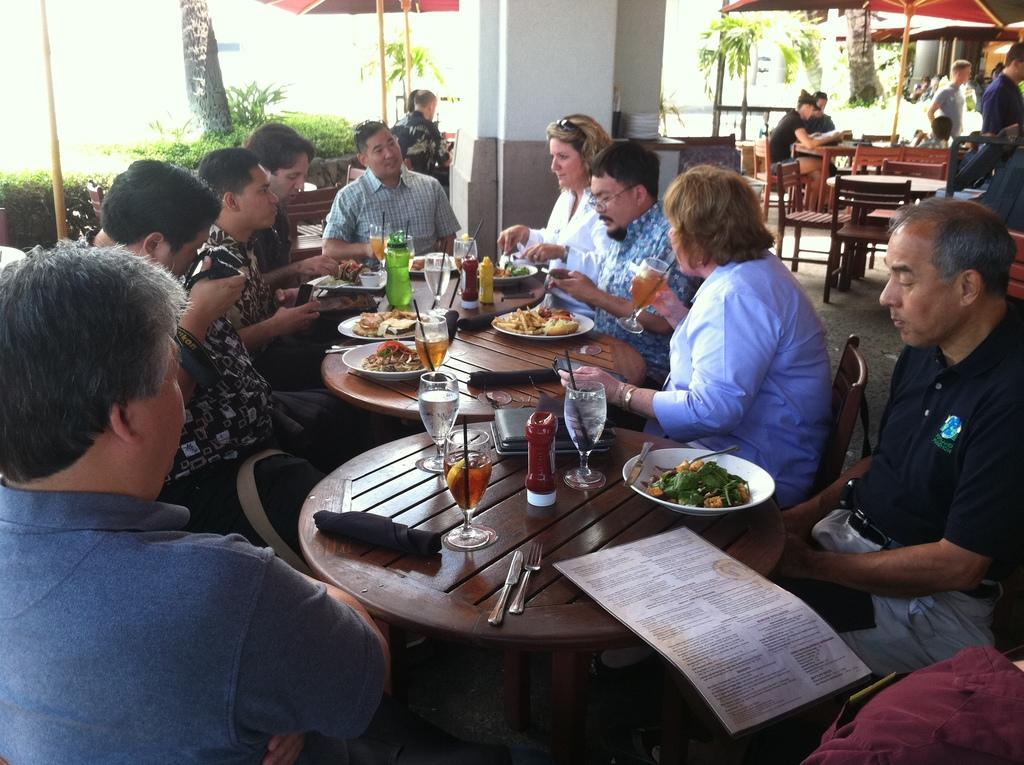Could you give a brief overview of what you see in this image? In this image, there are some persons sitting on the chair. There is a table behind these persons. This table contains food, glass of water, knife and fork. There are some plants behind these persons. There is an umbrella behind this table. This person holding spectacles on her head. 